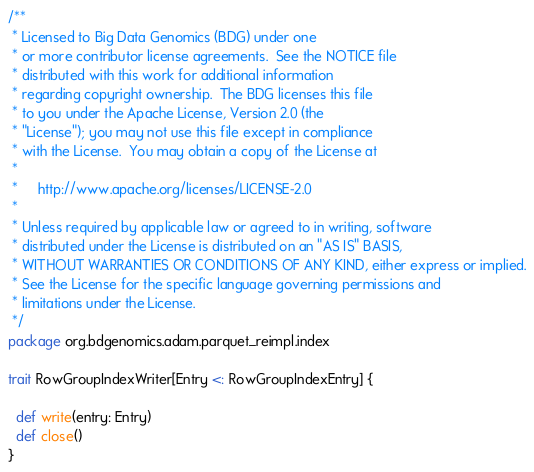<code> <loc_0><loc_0><loc_500><loc_500><_Scala_>/**
 * Licensed to Big Data Genomics (BDG) under one
 * or more contributor license agreements.  See the NOTICE file
 * distributed with this work for additional information
 * regarding copyright ownership.  The BDG licenses this file
 * to you under the Apache License, Version 2.0 (the
 * "License"); you may not use this file except in compliance
 * with the License.  You may obtain a copy of the License at
 *
 *     http://www.apache.org/licenses/LICENSE-2.0
 *
 * Unless required by applicable law or agreed to in writing, software
 * distributed under the License is distributed on an "AS IS" BASIS,
 * WITHOUT WARRANTIES OR CONDITIONS OF ANY KIND, either express or implied.
 * See the License for the specific language governing permissions and
 * limitations under the License.
 */
package org.bdgenomics.adam.parquet_reimpl.index

trait RowGroupIndexWriter[Entry <: RowGroupIndexEntry] {

  def write(entry: Entry)
  def close()
}
</code> 